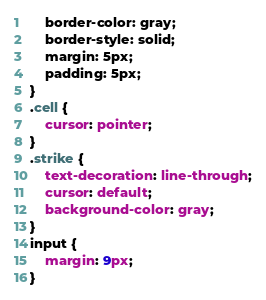<code> <loc_0><loc_0><loc_500><loc_500><_CSS_>	border-color: gray;
	border-style: solid;
	margin: 5px;
	padding: 5px;
}
.cell {
	cursor: pointer;
}
.strike {
	text-decoration: line-through;
	cursor: default;
	background-color: gray;
}
input {
	margin: 9px;
}</code> 